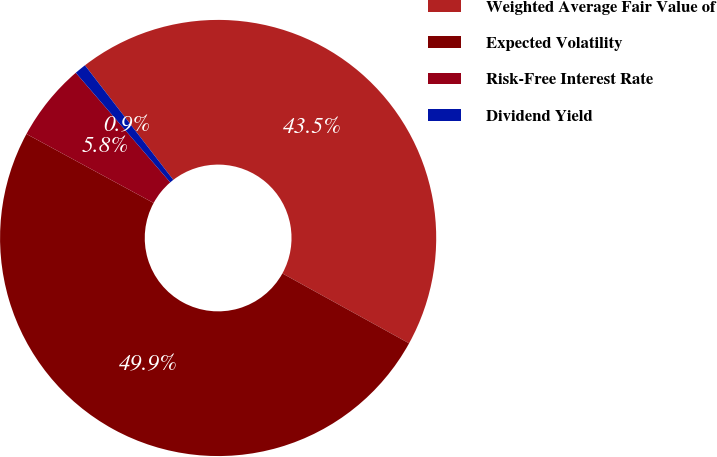Convert chart. <chart><loc_0><loc_0><loc_500><loc_500><pie_chart><fcel>Weighted Average Fair Value of<fcel>Expected Volatility<fcel>Risk-Free Interest Rate<fcel>Dividend Yield<nl><fcel>43.48%<fcel>49.89%<fcel>5.77%<fcel>0.86%<nl></chart> 